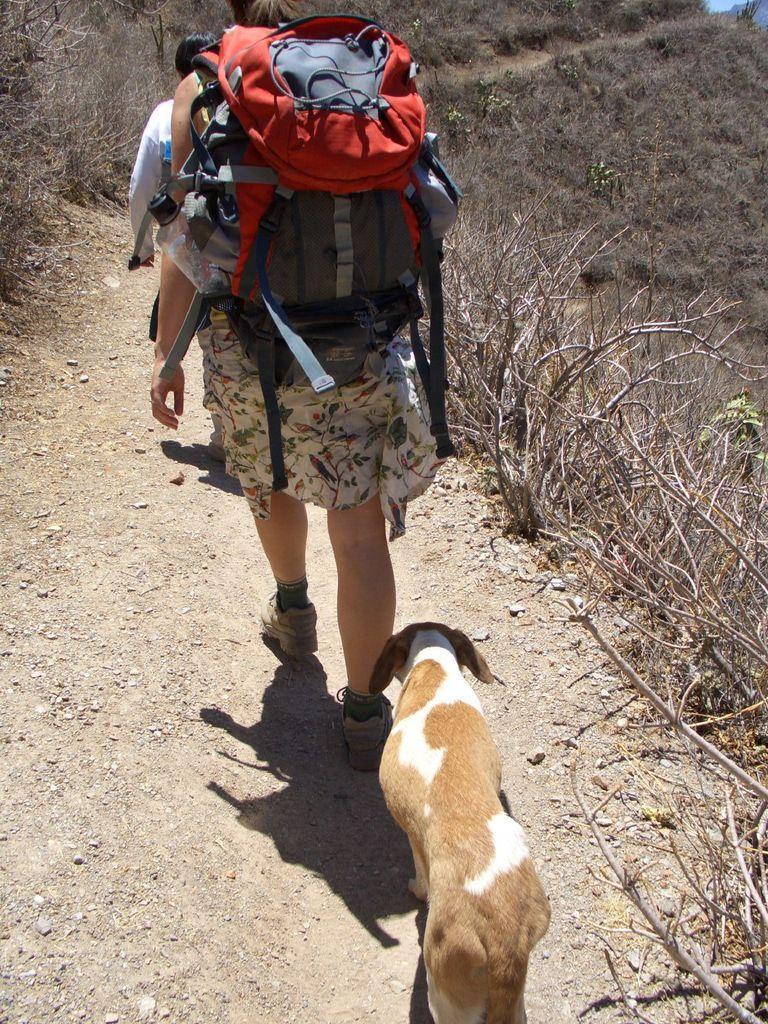Can you describe this image briefly? In this picture I can see there are two persons walking and they are wearing bags, there is a dog behind them and there are few dry plants at the right side. I can also see there are few plants in the backdrop. 